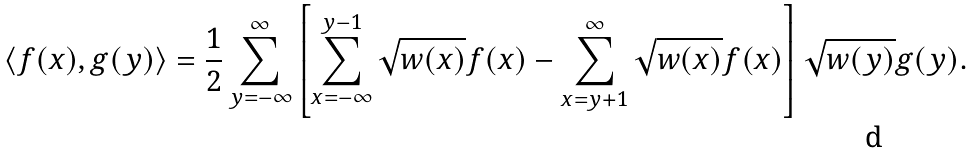Convert formula to latex. <formula><loc_0><loc_0><loc_500><loc_500>\langle f ( x ) , g ( y ) \rangle = \frac { 1 } { 2 } \sum _ { y = - \infty } ^ { \infty } \left [ \sum _ { x = - \infty } ^ { y - 1 } \sqrt { w ( x ) } f ( x ) - \sum _ { x = y + 1 } ^ { \infty } \sqrt { w ( x ) } f ( x ) \right ] \sqrt { w ( y ) } g ( y ) .</formula> 